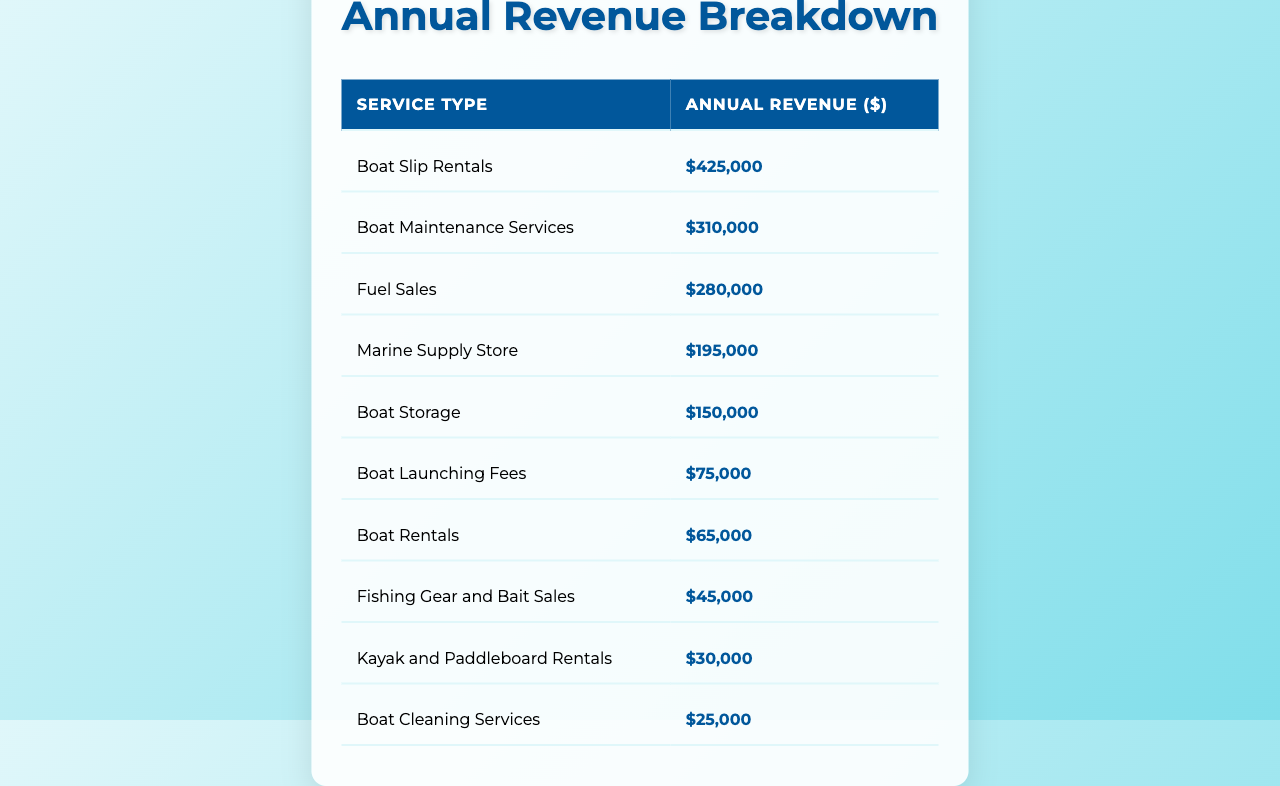What is the annual revenue from Boat Slip Rentals? The table shows that the annual revenue from Boat Slip Rentals is directly listed under the corresponding service type, which is $425,000.
Answer: $425,000 What service type has the lowest annual revenue? By inspecting the annual revenue figures in the table, it's clear that Boat Cleaning Services has the lowest revenue at $25,000.
Answer: Boat Cleaning Services What is the total annual revenue from all services combined? To find the total revenue, I add up all the revenue amounts: $425,000 + $310,000 + $280,000 + $195,000 + $150,000 + $75,000 + $65,000 + $45,000 + $30,000 + $25,000 = $1,600,000.
Answer: $1,600,000 Is the revenue from Fuel Sales greater than that from Boat Rentals? The table lists Fuel Sales revenue at $280,000 and Boat Rentals at $65,000. Since $280,000 is greater than $65,000, the statement is true.
Answer: Yes What is the average annual revenue across all services? To calculate the average, sum all the revenues ($1,600,000) and divide by the number of services (10): $1,600,000 / 10 = $160,000.
Answer: $160,000 What is the difference in revenue between Boat Maintenance Services and Boat Launching Fees? The revenue for Boat Maintenance Services is $310,000, while Boat Launching Fees is $75,000. The difference is $310,000 - $75,000 = $235,000.
Answer: $235,000 What percentage of the total revenue comes from Marine Supply Store sales? First, find the revenue from Marine Supply Store, which is $195,000. Then divide it by the total revenue ($1,600,000) and multiply by 100: ($195,000 / $1,600,000) * 100 = 12.1875%.
Answer: 12.19% How much more revenue does Boat Storage generate compared to Kayak and Paddleboard Rentals? The revenue for Boat Storage is $150,000 and for Kayak and Paddleboard Rentals is $30,000. The difference is $150,000 - $30,000 = $120,000 more from Boat Storage.
Answer: $120,000 Which service types generate a revenue above $200,000? By reviewing the table, Boat Slip Rentals ($425,000), Boat Maintenance Services ($310,000), and Fuel Sales ($280,000) all have revenues above $200,000.
Answer: Boat Slip Rentals, Boat Maintenance Services, Fuel Sales If we combine the revenues from Boat Rentals and Fishing Gear and Bait Sales, what would the total be? The revenue for Boat Rentals is $65,000 and for Fishing Gear and Bait Sales is $45,000. Adding these together gives $65,000 + $45,000 = $110,000.
Answer: $110,000 